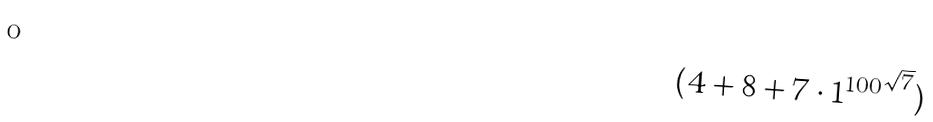<formula> <loc_0><loc_0><loc_500><loc_500>( 4 + 8 + 7 \cdot { 1 ^ { 1 0 0 } } ^ { \sqrt { 7 } } )</formula> 